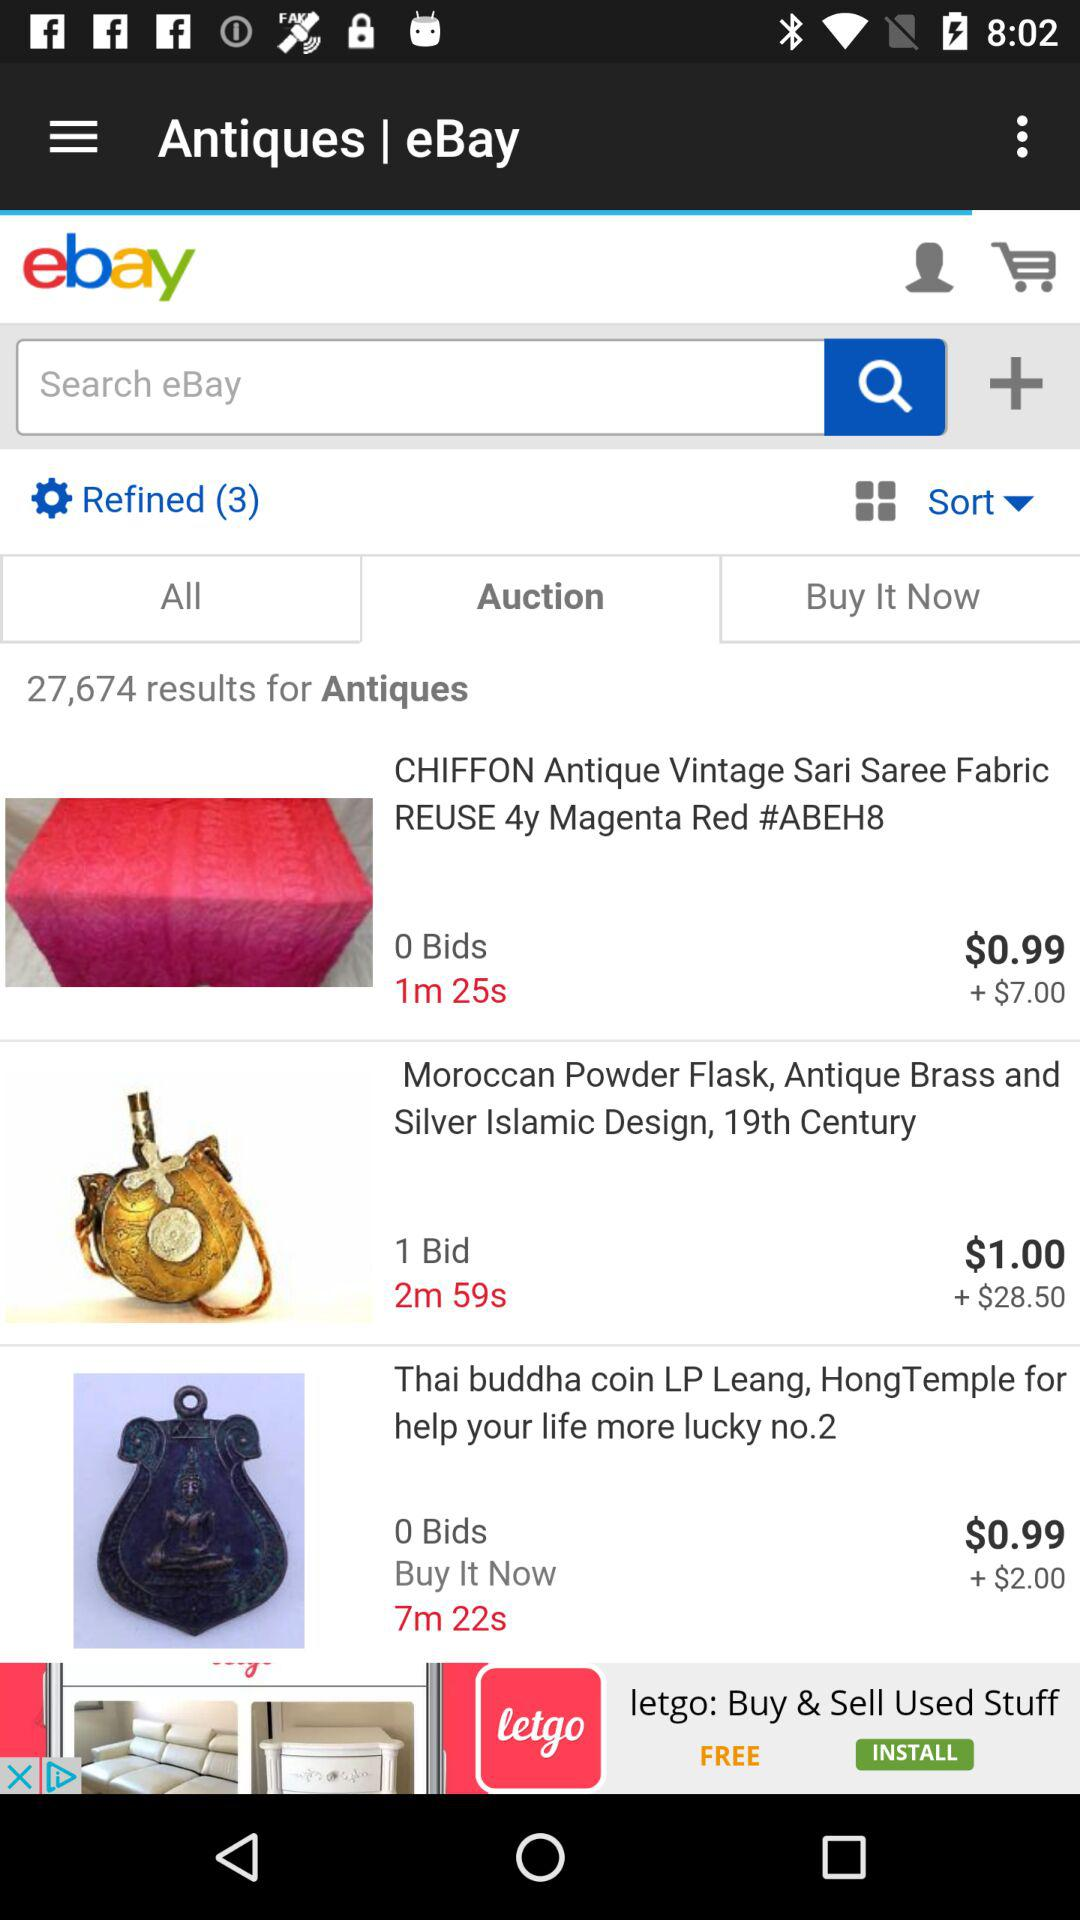What is the price of moroccan powder flask, antique brass and siver islamic design?
When the provided information is insufficient, respond with <no answer>. <no answer> 